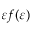Convert formula to latex. <formula><loc_0><loc_0><loc_500><loc_500>\varepsilon f ( \varepsilon )</formula> 